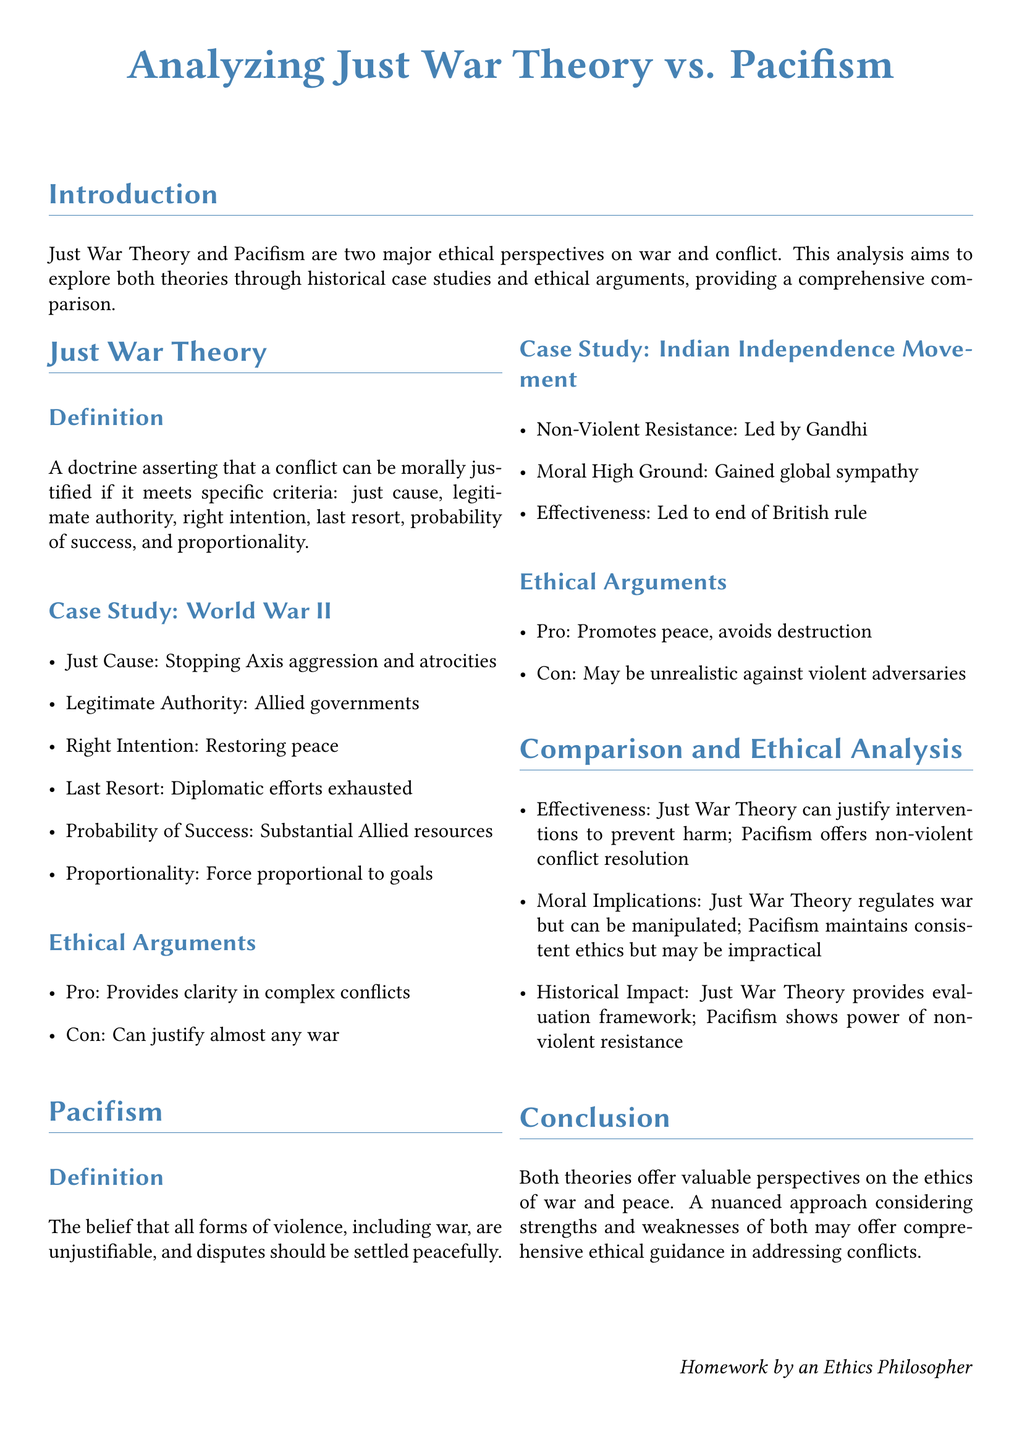What is the central theme of the document? The document explores ethical perspectives on war and conflict, specifically comparing Just War Theory and Pacifism.
Answer: Just War Theory vs. Pacifism What are the criteria for Just War Theory? The document lists six criteria for Just War Theory: just cause, legitimate authority, right intention, last resort, probability of success, and proportionality.
Answer: Just cause, legitimate authority, right intention, last resort, probability of success, proportionality Who led the non-violent resistance in the Indian Independence Movement? The document names Gandhi as the leader of the non-violent resistance during the Indian Independence Movement.
Answer: Gandhi What historical case study is associated with Just War Theory? The document cites World War II as the historical case study related to Just War Theory.
Answer: World War II What is a potential downside of Just War Theory mentioned in the document? The document states that Just War Theory can justify almost any war as a potential downside.
Answer: Can justify almost any war What is the main argument in favor of Pacifism? The document argues that Pacifism promotes peace and avoids destruction as its main favorable aspect.
Answer: Promotes peace, avoids destruction What is a moral implication of Pacifism discussed in the text? The document suggests that Pacifism maintains consistent ethics but may be impractical against violent adversaries as a moral implication.
Answer: May be impractical against violent adversaries How does the document suggest evaluating the effectiveness of both theories? It mentions that Just War Theory can justify interventions to prevent harm, while Pacifism offers non-violent conflict resolution.
Answer: Just War Theory justifies interventions; Pacifism offers non-violent resolution What is the final conclusion of the analysis in the document? The document concludes that both theories offer valuable perspectives and a nuanced approach considering strengths and weaknesses may provide ethical guidance.
Answer: A nuanced approach may offer comprehensive ethical guidance 